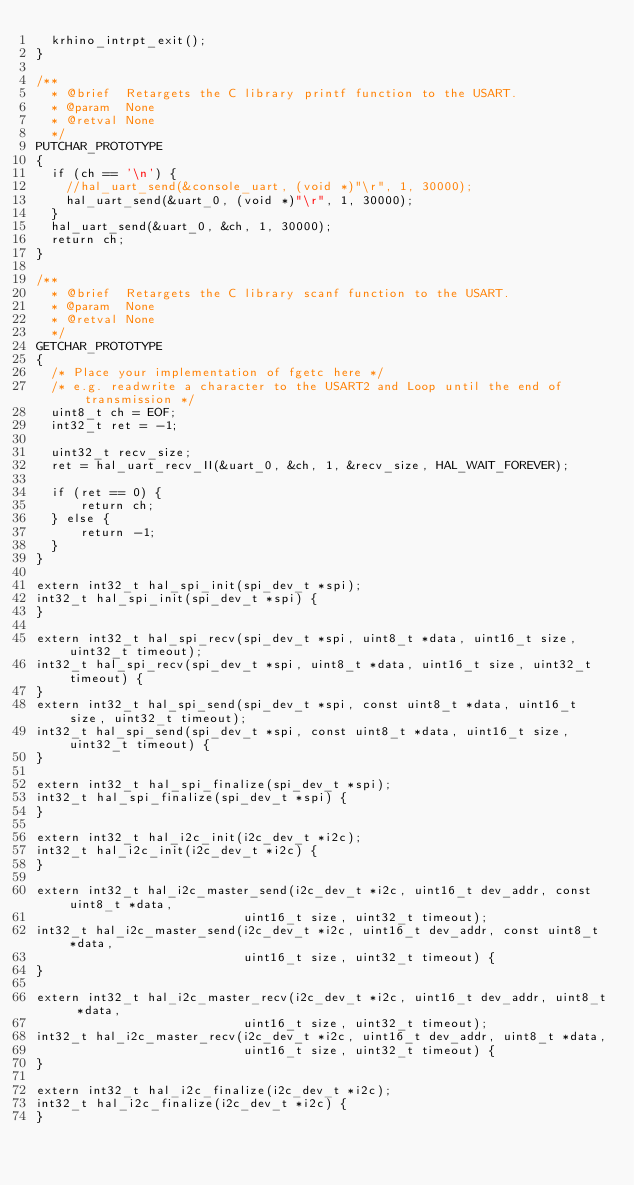Convert code to text. <code><loc_0><loc_0><loc_500><loc_500><_C_>  krhino_intrpt_exit();
}

/**
  * @brief  Retargets the C library printf function to the USART.
  * @param  None
  * @retval None
  */
PUTCHAR_PROTOTYPE
{
  if (ch == '\n') {
    //hal_uart_send(&console_uart, (void *)"\r", 1, 30000);
    hal_uart_send(&uart_0, (void *)"\r", 1, 30000);
  }
  hal_uart_send(&uart_0, &ch, 1, 30000);
  return ch;
}

/**
  * @brief  Retargets the C library scanf function to the USART.
  * @param  None
  * @retval None
  */
GETCHAR_PROTOTYPE
{
  /* Place your implementation of fgetc here */
  /* e.g. readwrite a character to the USART2 and Loop until the end of transmission */
  uint8_t ch = EOF;
  int32_t ret = -1;
  
  uint32_t recv_size;
  ret = hal_uart_recv_II(&uart_0, &ch, 1, &recv_size, HAL_WAIT_FOREVER);

  if (ret == 0) {
      return ch;
  } else {
      return -1;
  }
}

extern int32_t hal_spi_init(spi_dev_t *spi);
int32_t hal_spi_init(spi_dev_t *spi) {
}

extern int32_t hal_spi_recv(spi_dev_t *spi, uint8_t *data, uint16_t size, uint32_t timeout);
int32_t hal_spi_recv(spi_dev_t *spi, uint8_t *data, uint16_t size, uint32_t timeout) { 
}
extern int32_t hal_spi_send(spi_dev_t *spi, const uint8_t *data, uint16_t size, uint32_t timeout);
int32_t hal_spi_send(spi_dev_t *spi, const uint8_t *data, uint16_t size, uint32_t timeout) {
}

extern int32_t hal_spi_finalize(spi_dev_t *spi);
int32_t hal_spi_finalize(spi_dev_t *spi) {
}

extern int32_t hal_i2c_init(i2c_dev_t *i2c);
int32_t hal_i2c_init(i2c_dev_t *i2c) {
}

extern int32_t hal_i2c_master_send(i2c_dev_t *i2c, uint16_t dev_addr, const uint8_t *data,
                            uint16_t size, uint32_t timeout);
int32_t hal_i2c_master_send(i2c_dev_t *i2c, uint16_t dev_addr, const uint8_t *data,
                            uint16_t size, uint32_t timeout) {
}

extern int32_t hal_i2c_master_recv(i2c_dev_t *i2c, uint16_t dev_addr, uint8_t *data,
                            uint16_t size, uint32_t timeout);
int32_t hal_i2c_master_recv(i2c_dev_t *i2c, uint16_t dev_addr, uint8_t *data,
                            uint16_t size, uint32_t timeout) {
}

extern int32_t hal_i2c_finalize(i2c_dev_t *i2c);
int32_t hal_i2c_finalize(i2c_dev_t *i2c) {
}
</code> 